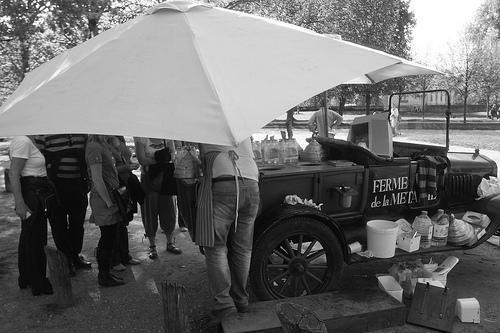How many wheels are in the photo?
Give a very brief answer. 1. 